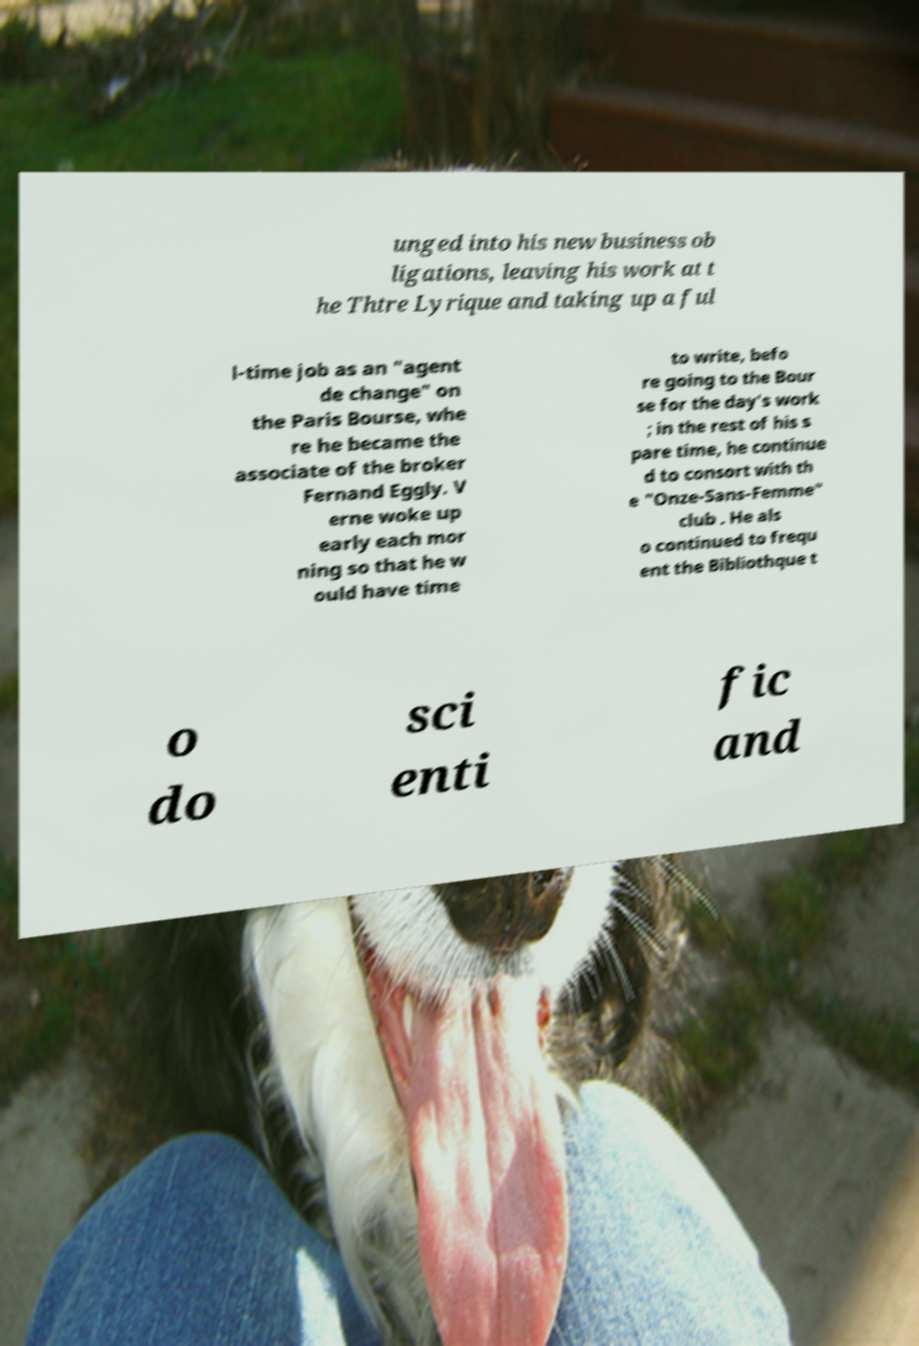Please identify and transcribe the text found in this image. unged into his new business ob ligations, leaving his work at t he Thtre Lyrique and taking up a ful l-time job as an "agent de change" on the Paris Bourse, whe re he became the associate of the broker Fernand Eggly. V erne woke up early each mor ning so that he w ould have time to write, befo re going to the Bour se for the day's work ; in the rest of his s pare time, he continue d to consort with th e "Onze-Sans-Femme" club . He als o continued to frequ ent the Bibliothque t o do sci enti fic and 